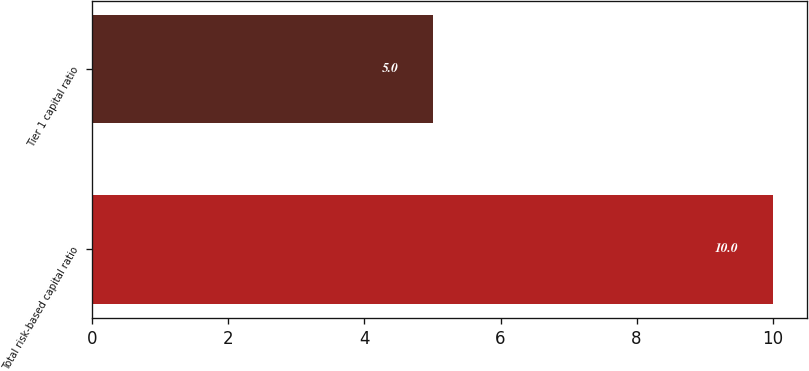Convert chart to OTSL. <chart><loc_0><loc_0><loc_500><loc_500><bar_chart><fcel>Total risk-based capital ratio<fcel>Tier 1 capital ratio<nl><fcel>10<fcel>5<nl></chart> 